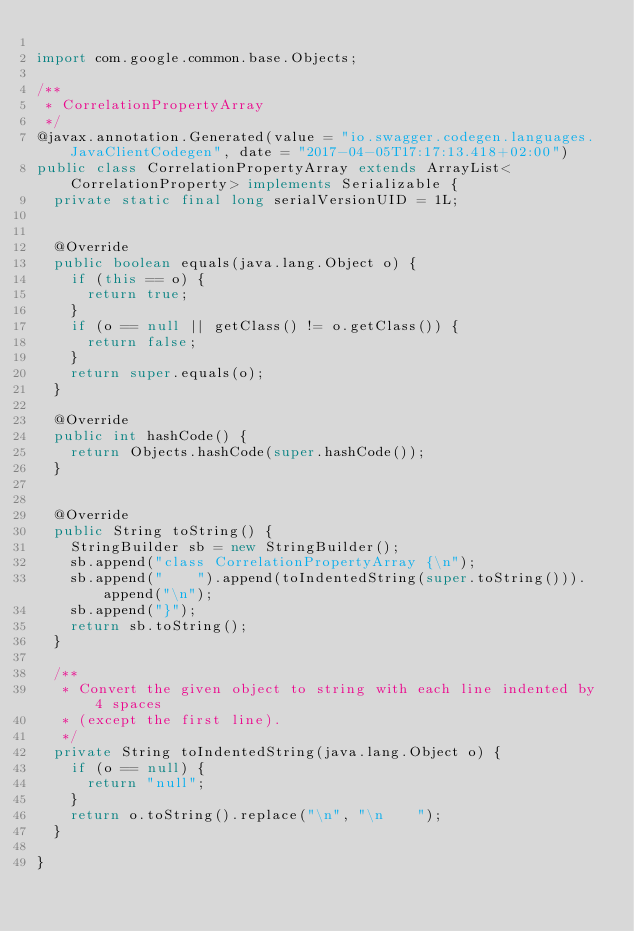Convert code to text. <code><loc_0><loc_0><loc_500><loc_500><_Java_>
import com.google.common.base.Objects;

/**
 * CorrelationPropertyArray
 */
@javax.annotation.Generated(value = "io.swagger.codegen.languages.JavaClientCodegen", date = "2017-04-05T17:17:13.418+02:00")
public class CorrelationPropertyArray extends ArrayList<CorrelationProperty> implements Serializable {
  private static final long serialVersionUID = 1L;


  @Override
  public boolean equals(java.lang.Object o) {
    if (this == o) {
      return true;
    }
    if (o == null || getClass() != o.getClass()) {
      return false;
    }
    return super.equals(o);
  }

  @Override
  public int hashCode() {
    return Objects.hashCode(super.hashCode());
  }


  @Override
  public String toString() {
    StringBuilder sb = new StringBuilder();
    sb.append("class CorrelationPropertyArray {\n");
    sb.append("    ").append(toIndentedString(super.toString())).append("\n");
    sb.append("}");
    return sb.toString();
  }

  /**
   * Convert the given object to string with each line indented by 4 spaces
   * (except the first line).
   */
  private String toIndentedString(java.lang.Object o) {
    if (o == null) {
      return "null";
    }
    return o.toString().replace("\n", "\n    ");
  }
  
}

</code> 